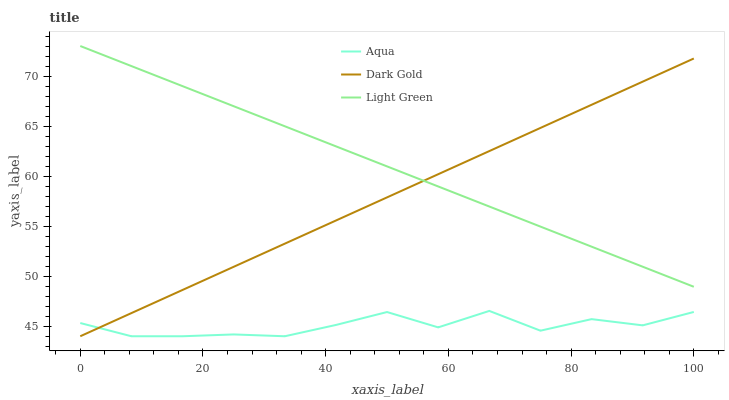Does Dark Gold have the minimum area under the curve?
Answer yes or no. No. Does Dark Gold have the maximum area under the curve?
Answer yes or no. No. Is Light Green the smoothest?
Answer yes or no. No. Is Light Green the roughest?
Answer yes or no. No. Does Light Green have the lowest value?
Answer yes or no. No. Does Dark Gold have the highest value?
Answer yes or no. No. Is Aqua less than Light Green?
Answer yes or no. Yes. Is Light Green greater than Aqua?
Answer yes or no. Yes. Does Aqua intersect Light Green?
Answer yes or no. No. 